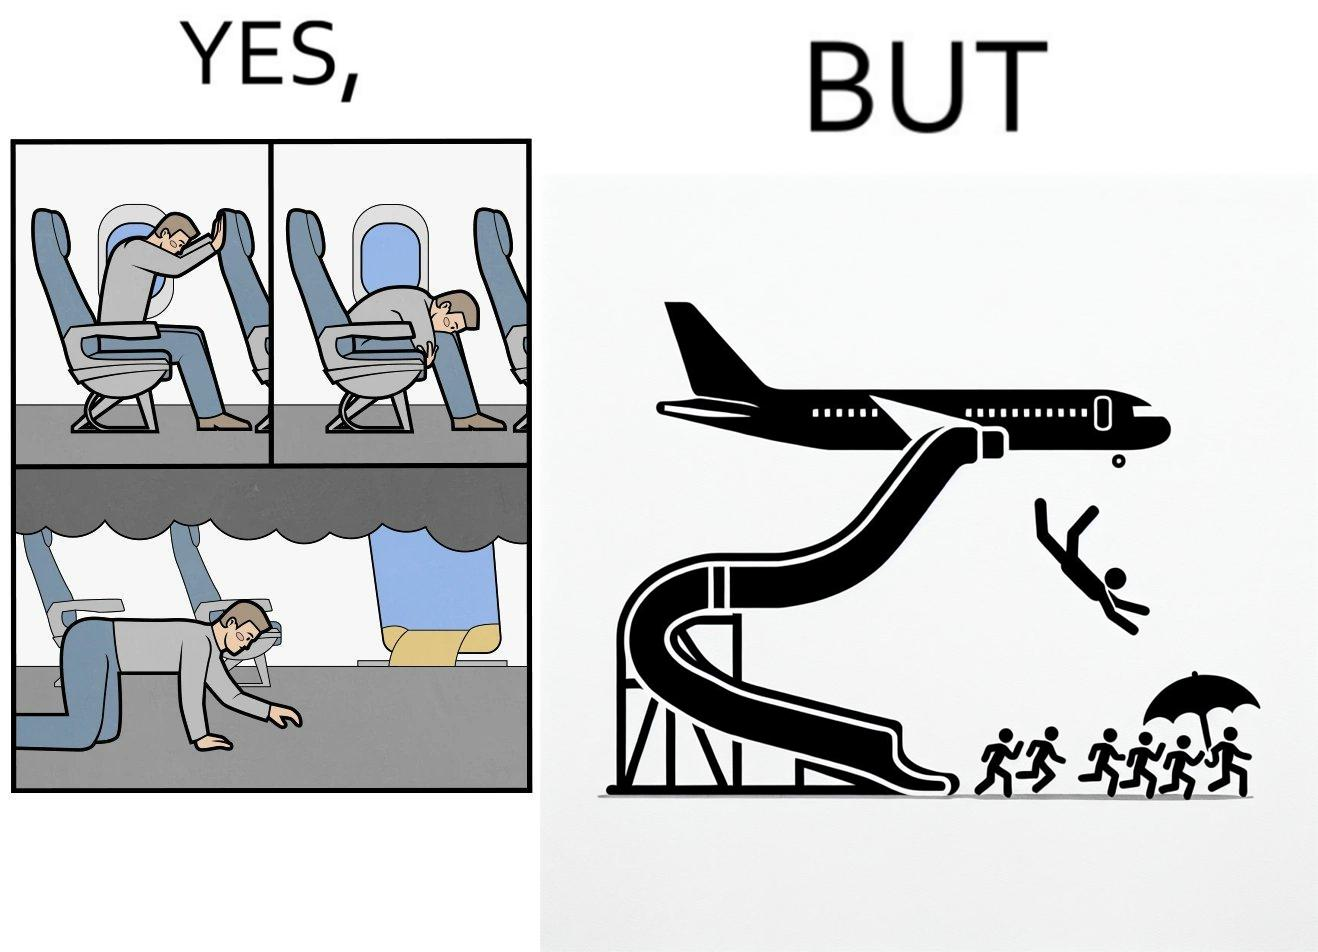Compare the left and right sides of this image. In the left part of the image: They are images of what one should do in an airplane in case of an imminent collision and fire In the right part of the image: It shows a man jumping out of an airplane in case of an emergency and using the emergency inflatable slides 